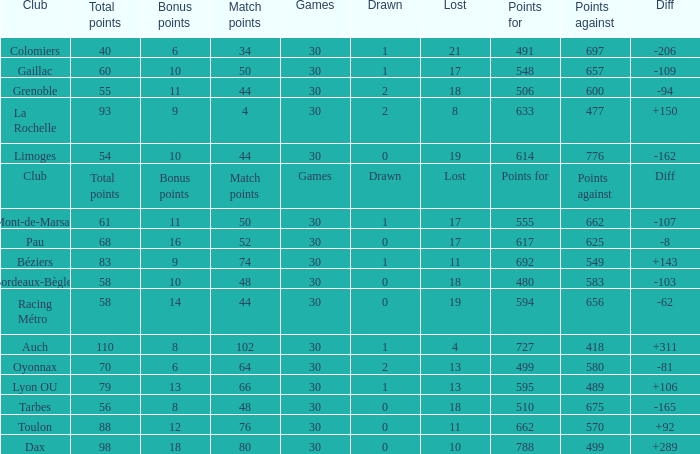What is the number of games for a club that has a value of 595 for points for? 30.0. 